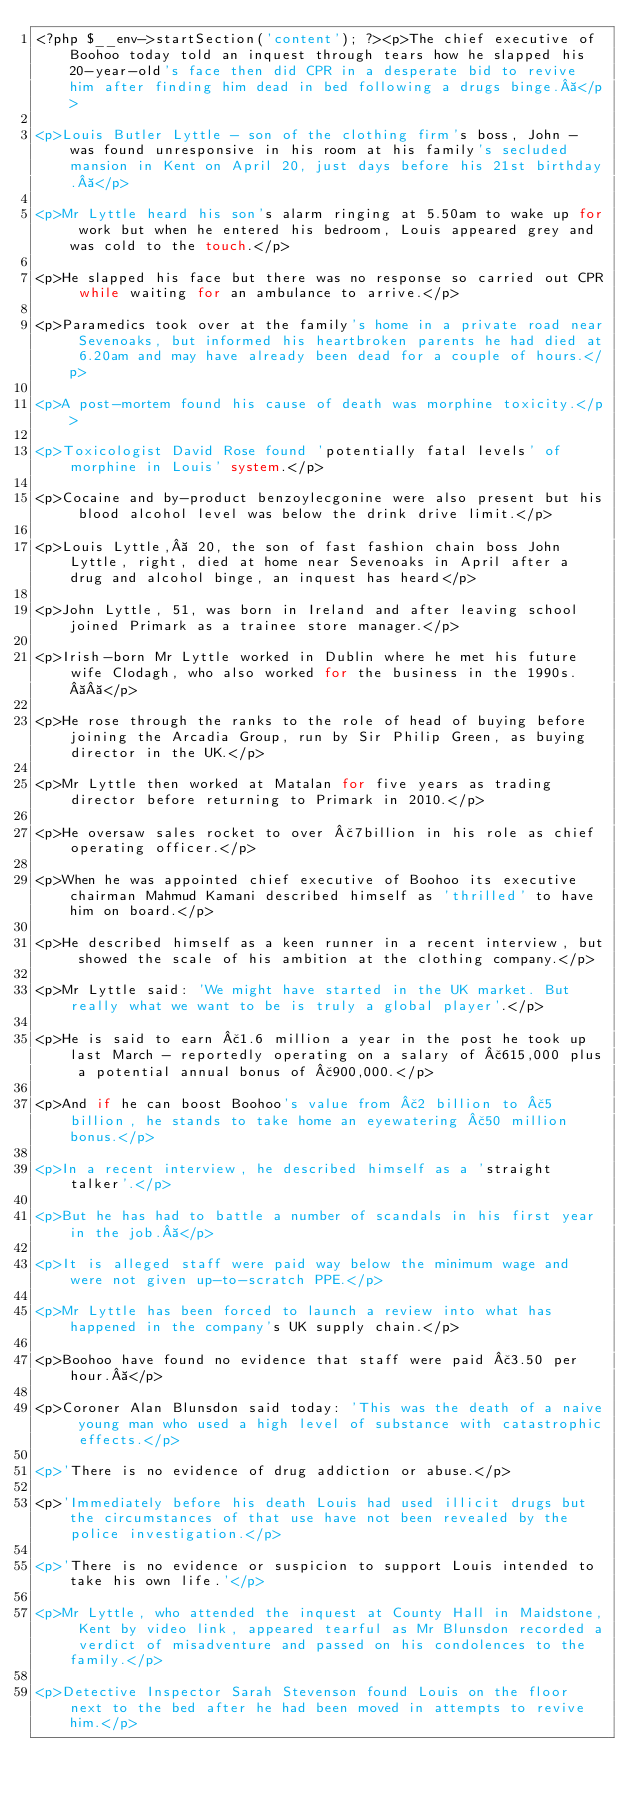Convert code to text. <code><loc_0><loc_0><loc_500><loc_500><_PHP_><?php $__env->startSection('content'); ?><p>The chief executive of Boohoo today told an inquest through tears how he slapped his 20-year-old's face then did CPR in a desperate bid to revive him after finding him dead in bed following a drugs binge. </p>

<p>Louis Butler Lyttle - son of the clothing firm's boss, John - was found unresponsive in his room at his family's secluded mansion in Kent on April 20, just days before his 21st birthday. </p>

<p>Mr Lyttle heard his son's alarm ringing at 5.50am to wake up for work but when he entered his bedroom, Louis appeared grey and was cold to the touch.</p>

<p>He slapped his face but there was no response so carried out CPR while waiting for an ambulance to arrive.</p>

<p>Paramedics took over at the family's home in a private road near Sevenoaks, but informed his heartbroken parents he had died at 6.20am and may have already been dead for a couple of hours.</p>

<p>A post-mortem found his cause of death was morphine toxicity.</p>

<p>Toxicologist David Rose found 'potentially fatal levels' of morphine in Louis' system.</p>

<p>Cocaine and by-product benzoylecgonine were also present but his blood alcohol level was below the drink drive limit.</p>

<p>Louis Lyttle,  20, the son of fast fashion chain boss John Lyttle, right, died at home near Sevenoaks in April after a drug and alcohol binge, an inquest has heard</p>

<p>John Lyttle, 51, was born in Ireland and after leaving school joined Primark as a trainee store manager.</p>

<p>Irish-born Mr Lyttle worked in Dublin where he met his future wife Clodagh, who also worked for the business in the 1990s.  </p>

<p>He rose through the ranks to the role of head of buying before joining the Arcadia Group, run by Sir Philip Green, as buying director in the UK.</p>

<p>Mr Lyttle then worked at Matalan for five years as trading director before returning to Primark in 2010.</p>

<p>He oversaw sales rocket to over £7billion in his role as chief operating officer.</p>

<p>When he was appointed chief executive of Boohoo its executive chairman Mahmud Kamani described himself as 'thrilled' to have him on board.</p>

<p>He described himself as a keen runner in a recent interview, but showed the scale of his ambition at the clothing company.</p>

<p>Mr Lyttle said: 'We might have started in the UK market. But really what we want to be is truly a global player'.</p>

<p>He is said to earn £1.6 million a year in the post he took up last March - reportedly operating on a salary of £615,000 plus a potential annual bonus of £900,000.</p>

<p>And if he can boost Boohoo's value from £2 billion to £5 billion, he stands to take home an eyewatering £50 million bonus.</p>

<p>In a recent interview, he described himself as a 'straight talker'.</p>

<p>But he has had to battle a number of scandals in his first year in the job. </p>

<p>It is alleged staff were paid way below the minimum wage and were not given up-to-scratch PPE.</p>

<p>Mr Lyttle has been forced to launch a review into what has happened in the company's UK supply chain.</p>

<p>Boohoo have found no evidence that staff were paid £3.50 per hour. </p>

<p>Coroner Alan Blunsdon said today: 'This was the death of a naive young man who used a high level of substance with catastrophic effects.</p>

<p>'There is no evidence of drug addiction or abuse.</p>

<p>'Immediately before his death Louis had used illicit drugs but the circumstances of that use have not been revealed by the police investigation.</p>

<p>'There is no evidence or suspicion to support Louis intended to take his own life.'</p>

<p>Mr Lyttle, who attended the inquest at County Hall in Maidstone, Kent by video link, appeared tearful as Mr Blunsdon recorded a verdict of misadventure and passed on his condolences to the family.</p>

<p>Detective Inspector Sarah Stevenson found Louis on the floor next to the bed after he had been moved in attempts to revive him.</p>
</code> 